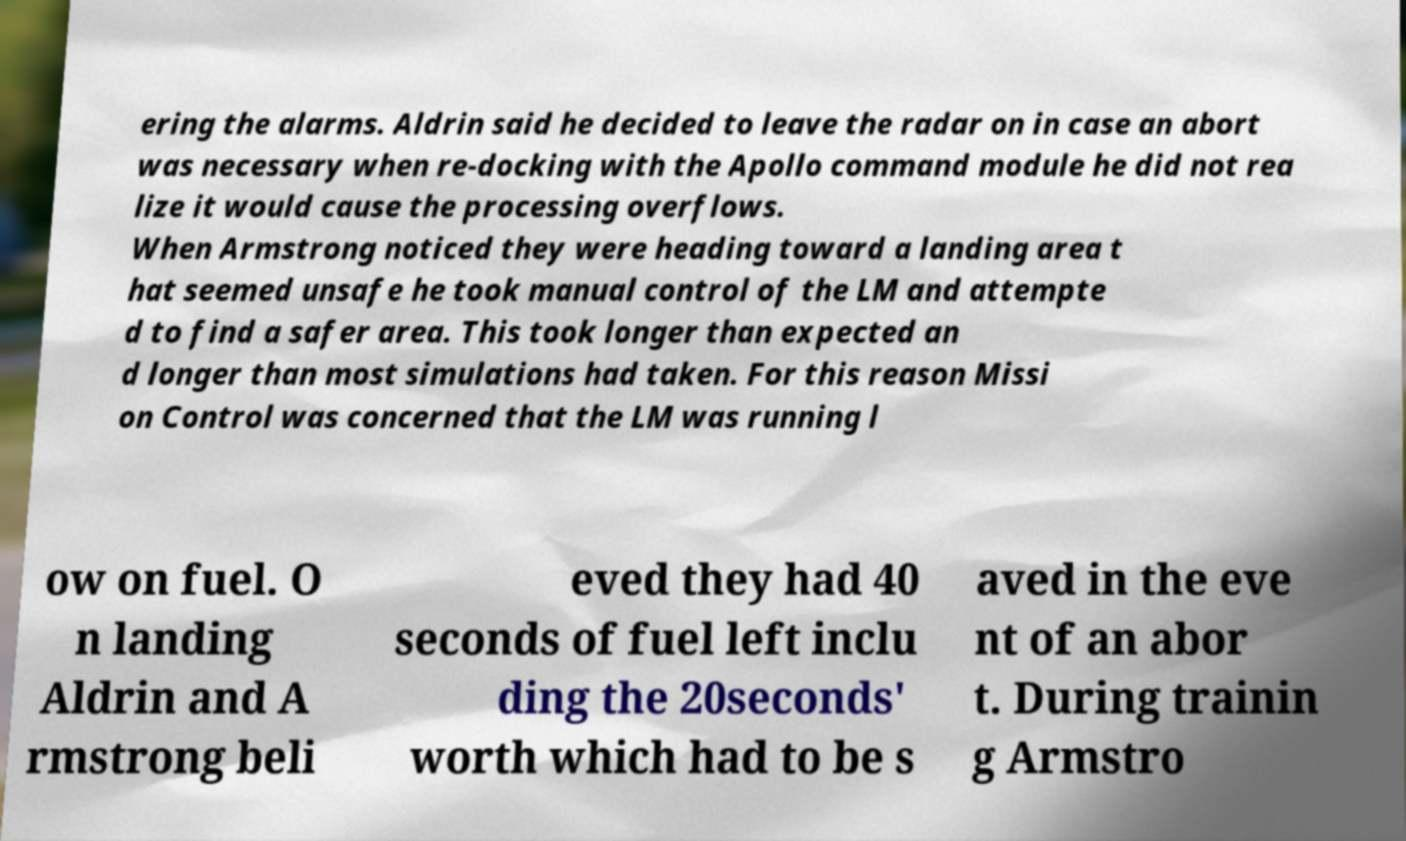Please identify and transcribe the text found in this image. ering the alarms. Aldrin said he decided to leave the radar on in case an abort was necessary when re-docking with the Apollo command module he did not rea lize it would cause the processing overflows. When Armstrong noticed they were heading toward a landing area t hat seemed unsafe he took manual control of the LM and attempte d to find a safer area. This took longer than expected an d longer than most simulations had taken. For this reason Missi on Control was concerned that the LM was running l ow on fuel. O n landing Aldrin and A rmstrong beli eved they had 40 seconds of fuel left inclu ding the 20seconds' worth which had to be s aved in the eve nt of an abor t. During trainin g Armstro 